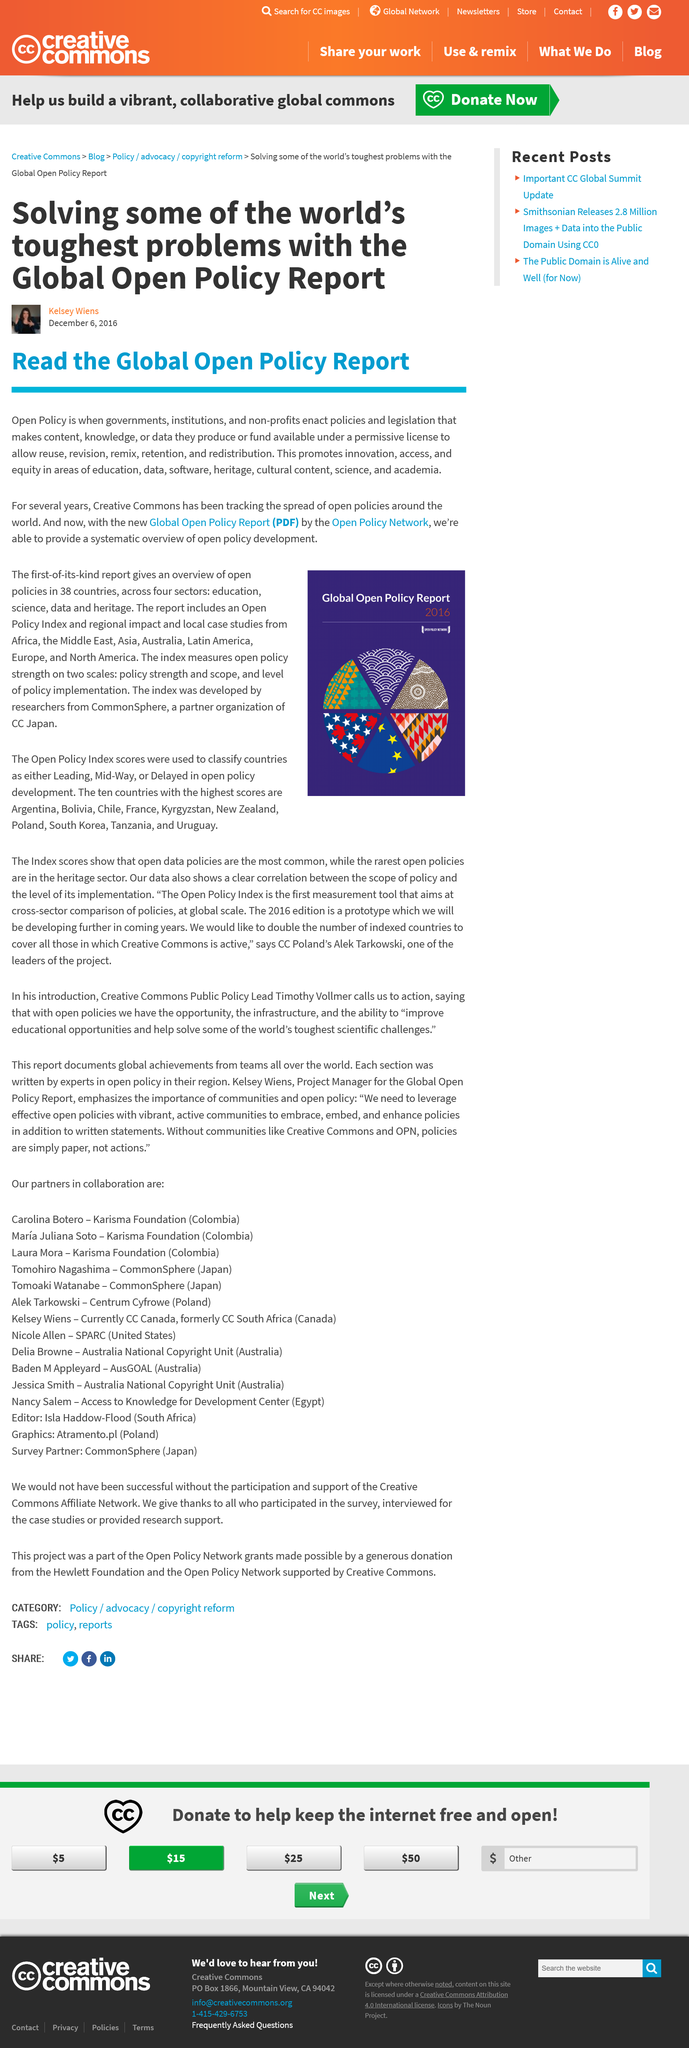Identify some key points in this picture. Kelsey Wiens' article is about solving some of the toughest problems using the Global Open Policy Report. Kelsey Wiers wrote the article on December 6, 2016. The article was written by Kelsey Wiers. 